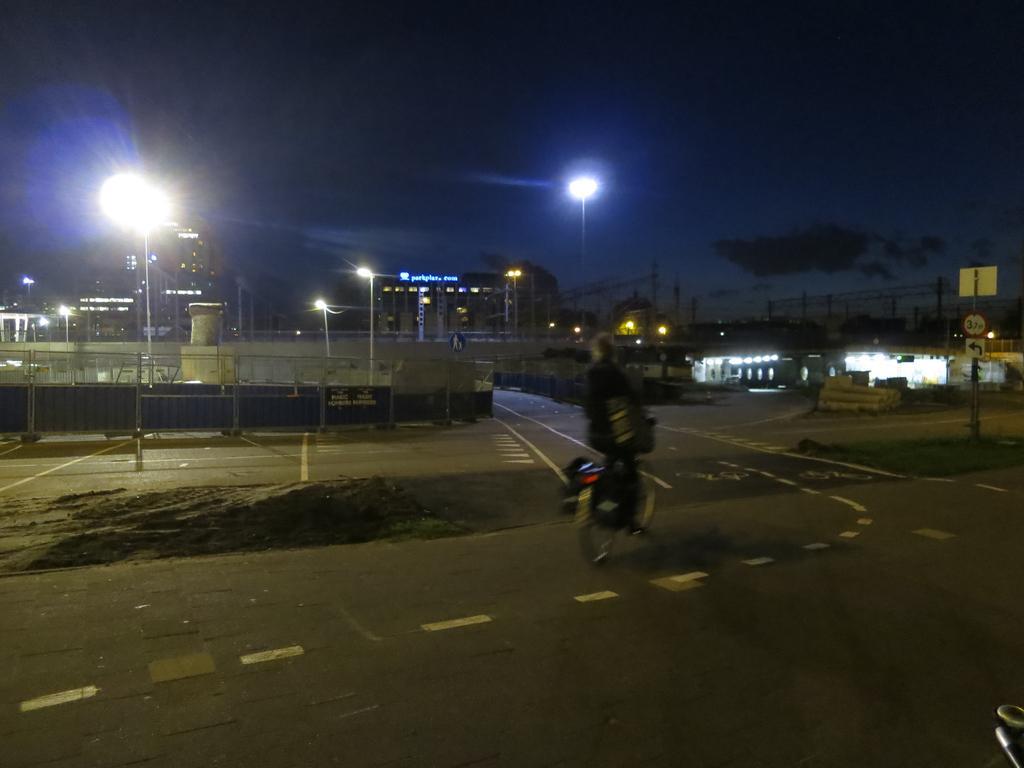Please provide a concise description of this image. In the center of the image we can see a person riding a bicycle on the road. On the left side of the image we can see a fence, a group of lights on poles. In the background, we can see buildings and the cloudy sky. 